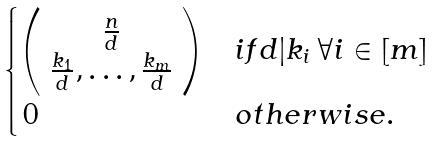Convert formula to latex. <formula><loc_0><loc_0><loc_500><loc_500>\begin{cases} \left ( \begin{array} { c } \frac { n } { d } \\ \frac { k _ { 1 } } d , \dots , \frac { k _ { m } } d \end{array} \right ) & i f d | k _ { i } \, \forall i \in [ m ] \\ \, 0 & o t h e r w i s e . \end{cases}</formula> 